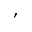Convert formula to latex. <formula><loc_0><loc_0><loc_500><loc_500>,</formula> 